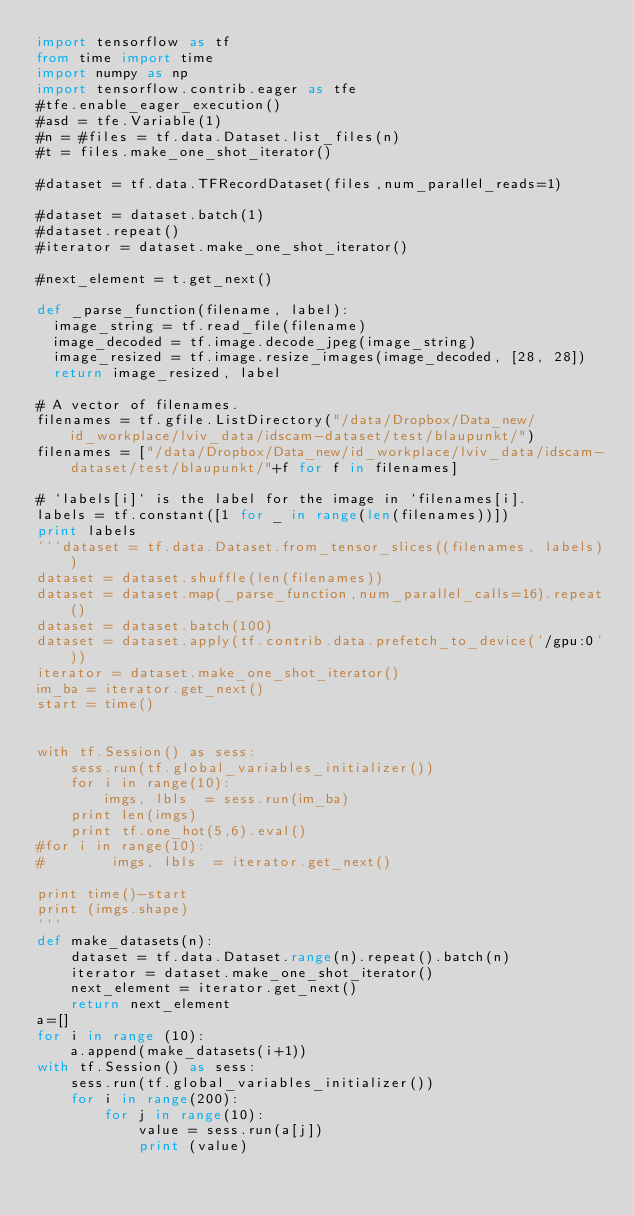<code> <loc_0><loc_0><loc_500><loc_500><_Python_>import tensorflow as tf
from time import time
import numpy as np
import tensorflow.contrib.eager as tfe
#tfe.enable_eager_execution()
#asd = tfe.Variable(1)
#n = #files = tf.data.Dataset.list_files(n)
#t = files.make_one_shot_iterator()

#dataset = tf.data.TFRecordDataset(files,num_parallel_reads=1)

#dataset = dataset.batch(1)
#dataset.repeat()
#iterator = dataset.make_one_shot_iterator()

#next_element = t.get_next()

def _parse_function(filename, label):
  image_string = tf.read_file(filename)
  image_decoded = tf.image.decode_jpeg(image_string)
  image_resized = tf.image.resize_images(image_decoded, [28, 28])
  return image_resized, label

# A vector of filenames.
filenames = tf.gfile.ListDirectory("/data/Dropbox/Data_new/id_workplace/lviv_data/idscam-dataset/test/blaupunkt/")
filenames = ["/data/Dropbox/Data_new/id_workplace/lviv_data/idscam-dataset/test/blaupunkt/"+f for f in filenames]

# `labels[i]` is the label for the image in `filenames[i].
labels = tf.constant([1 for _ in range(len(filenames))])
print labels
'''dataset = tf.data.Dataset.from_tensor_slices((filenames, labels))
dataset = dataset.shuffle(len(filenames))
dataset = dataset.map(_parse_function,num_parallel_calls=16).repeat()
dataset = dataset.batch(100)
dataset = dataset.apply(tf.contrib.data.prefetch_to_device('/gpu:0'))
iterator = dataset.make_one_shot_iterator()
im_ba = iterator.get_next()
start = time()


with tf.Session() as sess:
    sess.run(tf.global_variables_initializer())
    for i in range(10):
        imgs, lbls  = sess.run(im_ba)
    print len(imgs)
    print tf.one_hot(5,6).eval()
#for i in range(10):
#        imgs, lbls  = iterator.get_next()

print time()-start
print (imgs.shape)
'''
def make_datasets(n):
    dataset = tf.data.Dataset.range(n).repeat().batch(n)
    iterator = dataset.make_one_shot_iterator()
    next_element = iterator.get_next()
    return next_element
a=[]
for i in range (10):
    a.append(make_datasets(i+1))
with tf.Session() as sess:
    sess.run(tf.global_variables_initializer())
    for i in range(200):
        for j in range(10):
            value = sess.run(a[j])
            print (value)</code> 